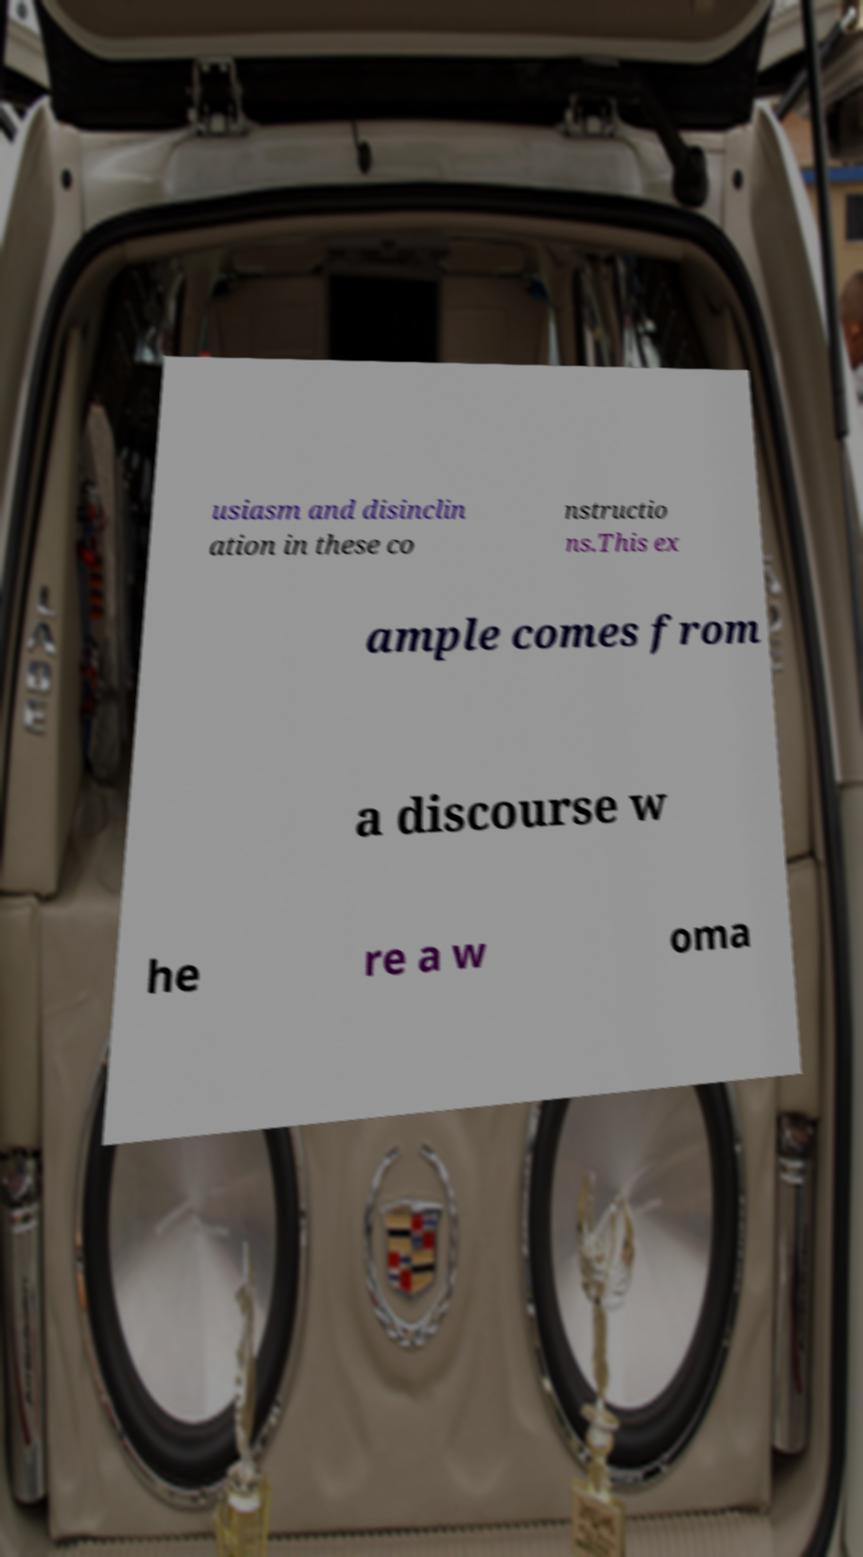Please read and relay the text visible in this image. What does it say? usiasm and disinclin ation in these co nstructio ns.This ex ample comes from a discourse w he re a w oma 